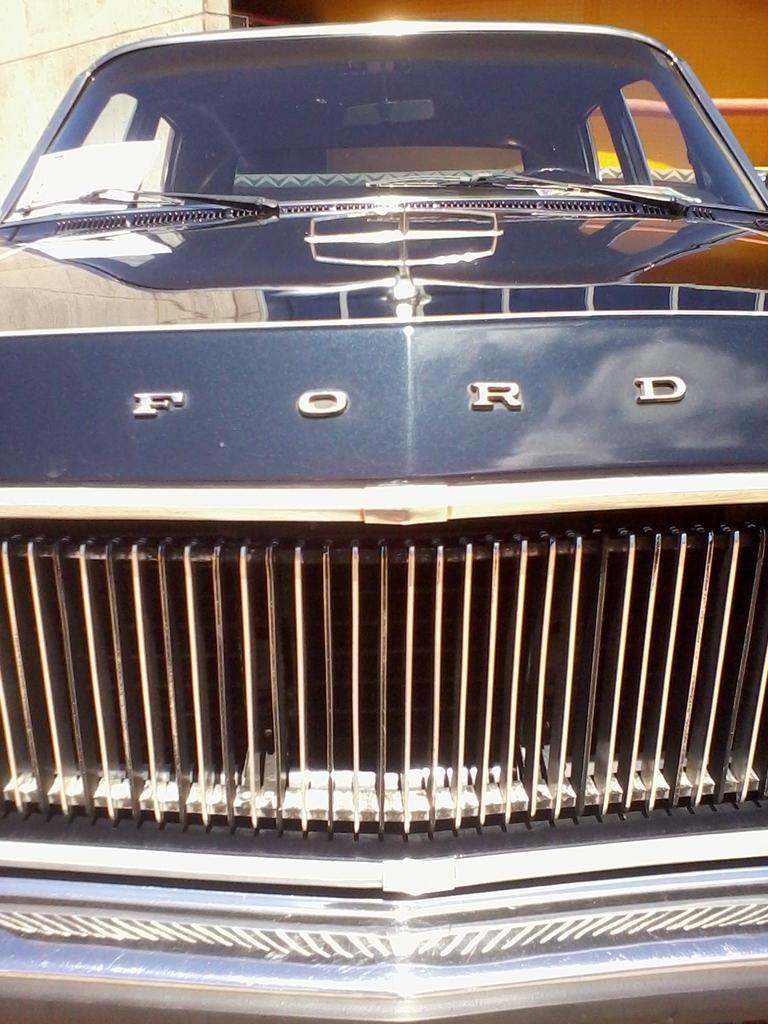In one or two sentences, can you explain what this image depicts? In this image I can see a car and on the front side of it I can see something is written. In the background I can see a building. 